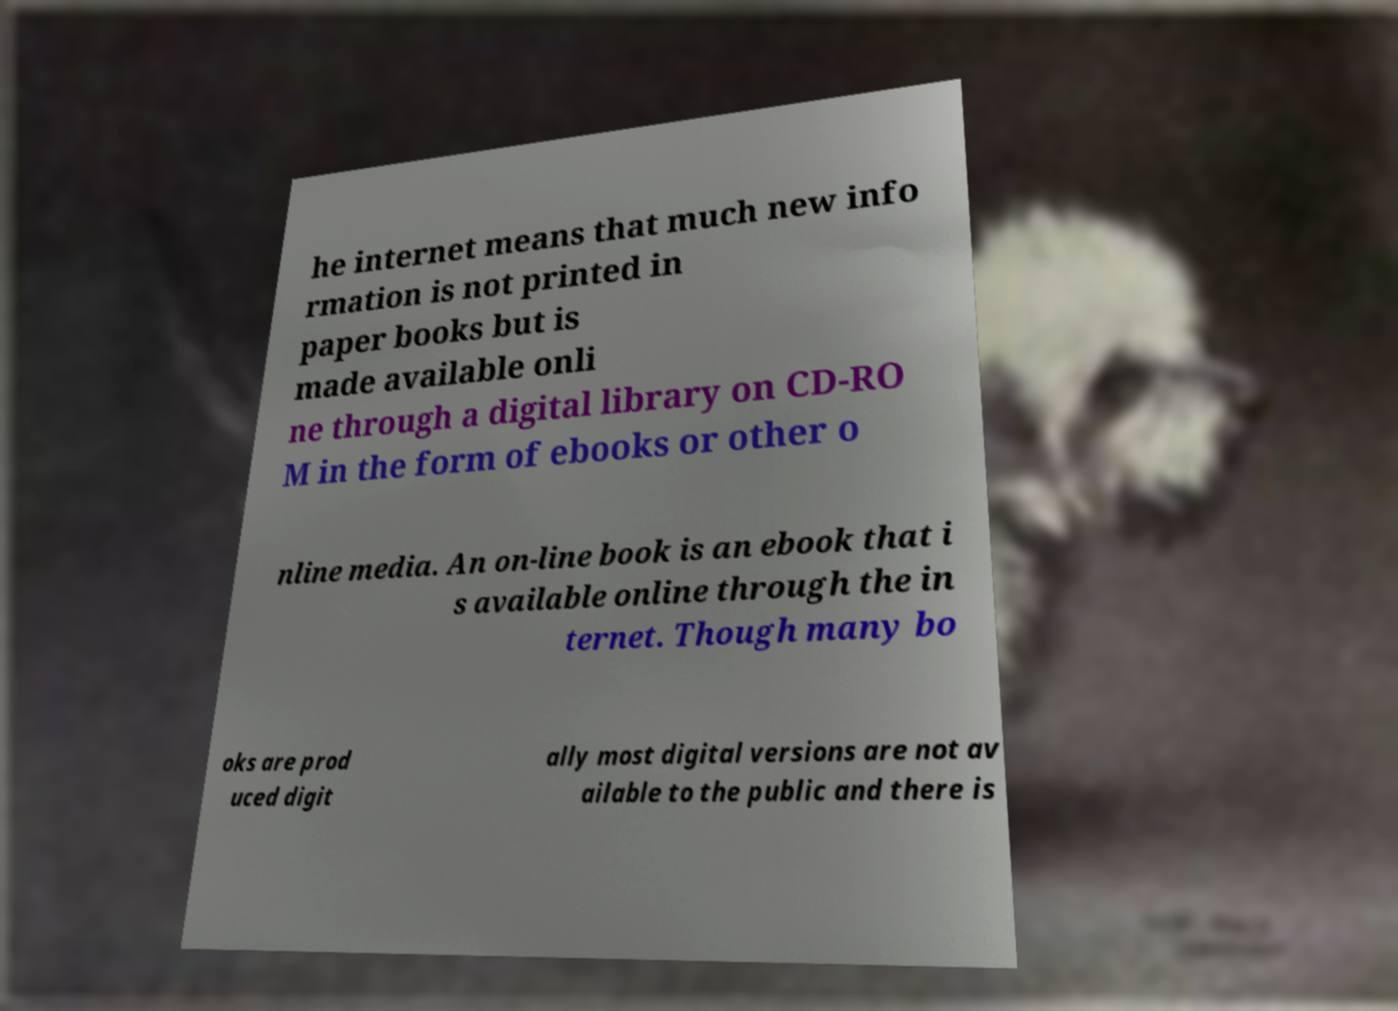For documentation purposes, I need the text within this image transcribed. Could you provide that? he internet means that much new info rmation is not printed in paper books but is made available onli ne through a digital library on CD-RO M in the form of ebooks or other o nline media. An on-line book is an ebook that i s available online through the in ternet. Though many bo oks are prod uced digit ally most digital versions are not av ailable to the public and there is 